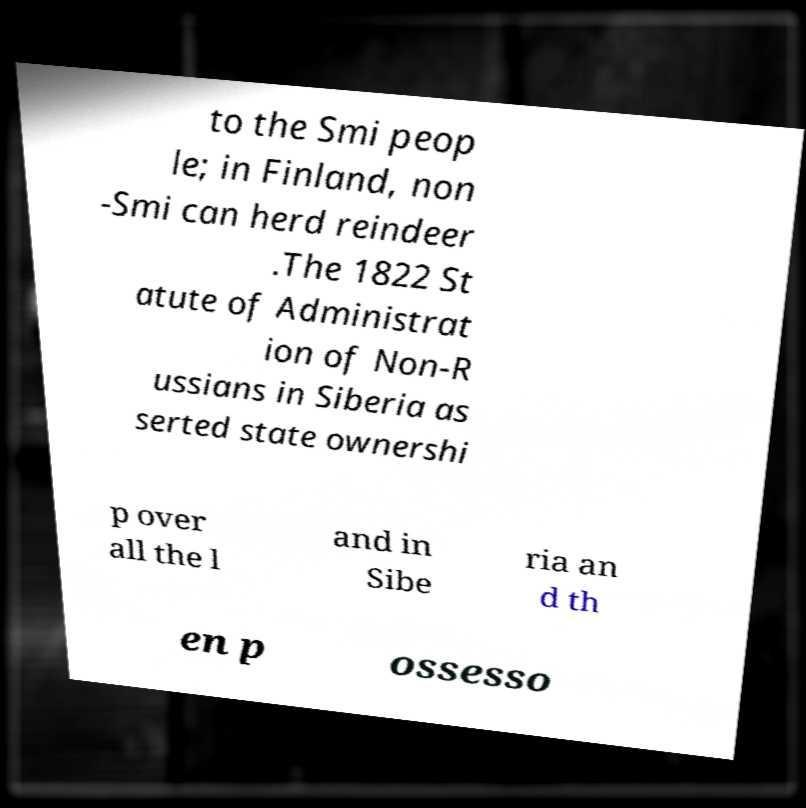There's text embedded in this image that I need extracted. Can you transcribe it verbatim? to the Smi peop le; in Finland, non -Smi can herd reindeer .The 1822 St atute of Administrat ion of Non-R ussians in Siberia as serted state ownershi p over all the l and in Sibe ria an d th en p ossesso 